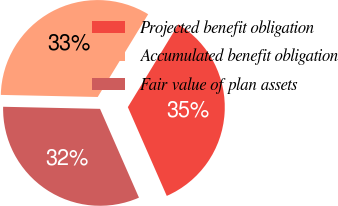Convert chart. <chart><loc_0><loc_0><loc_500><loc_500><pie_chart><fcel>Projected benefit obligation<fcel>Accumulated benefit obligation<fcel>Fair value of plan assets<nl><fcel>34.71%<fcel>33.37%<fcel>31.92%<nl></chart> 